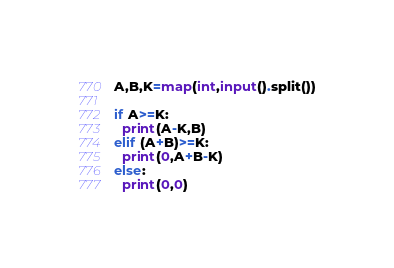Convert code to text. <code><loc_0><loc_0><loc_500><loc_500><_Python_>A,B,K=map(int,input().split())

if A>=K:
  print(A-K,B)
elif (A+B)>=K:
  print(0,A+B-K)
else:
  print(0,0)
</code> 